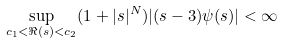Convert formula to latex. <formula><loc_0><loc_0><loc_500><loc_500>\sup _ { c _ { 1 } < \Re ( s ) < c _ { 2 } } ( 1 + | s | ^ { N } ) | ( s - 3 ) \psi ( s ) | < \infty</formula> 